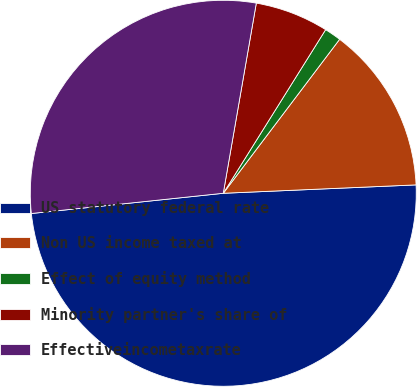Convert chart to OTSL. <chart><loc_0><loc_0><loc_500><loc_500><pie_chart><fcel>US statutory federal rate<fcel>Non US income taxed at<fcel>Effect of equity method<fcel>Minority partner's share of<fcel>Effectiveincometaxrate<nl><fcel>49.02%<fcel>14.01%<fcel>1.4%<fcel>6.16%<fcel>29.41%<nl></chart> 